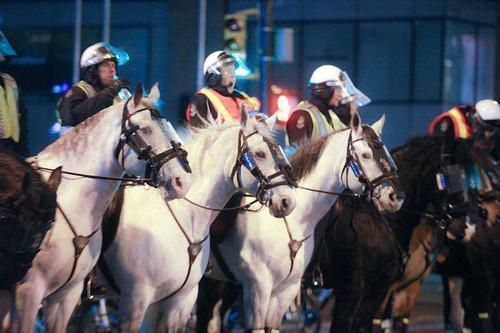How many white horses are there?
Give a very brief answer. 3. 